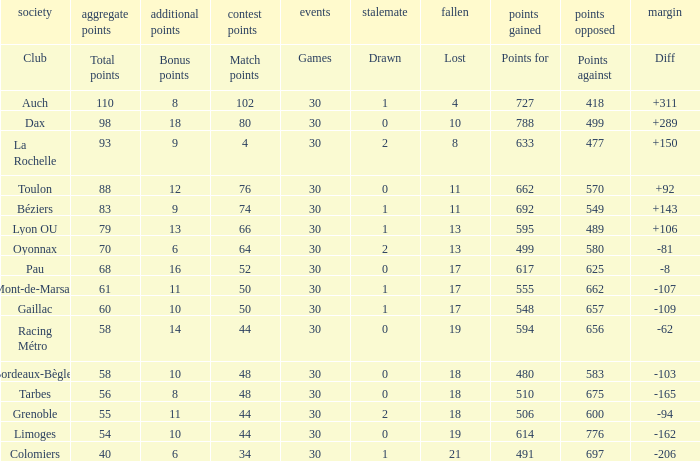What is the diff for a club that has a value of 662 for points for? 92.0. 